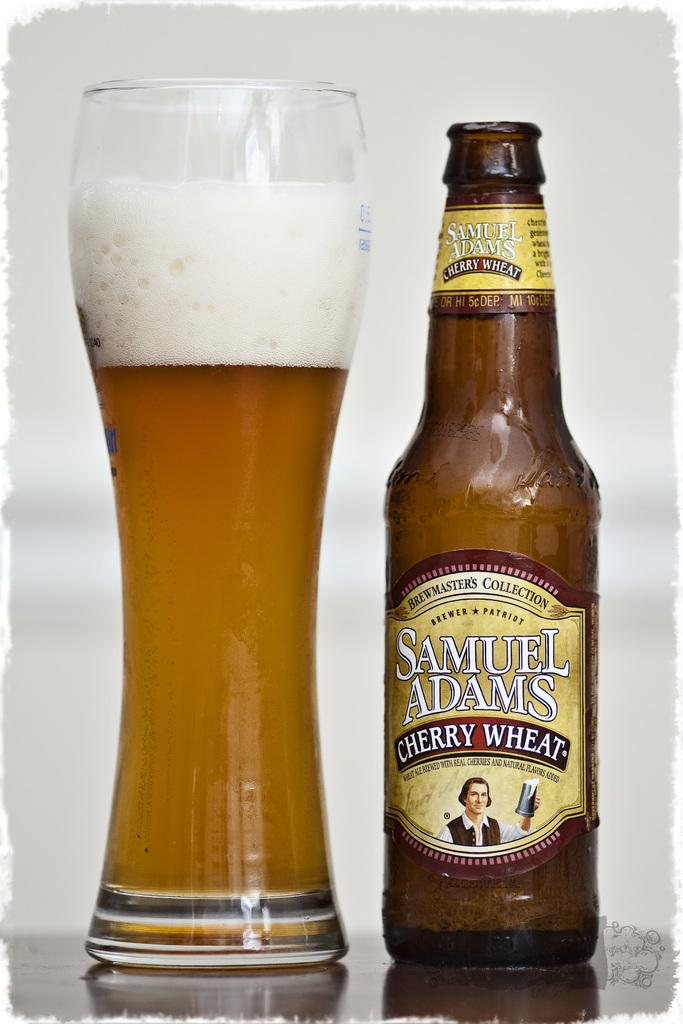<image>
Write a terse but informative summary of the picture. A Samuel Adams Cherry Wheat beer bottle and a tall pint glass filled with beer. 